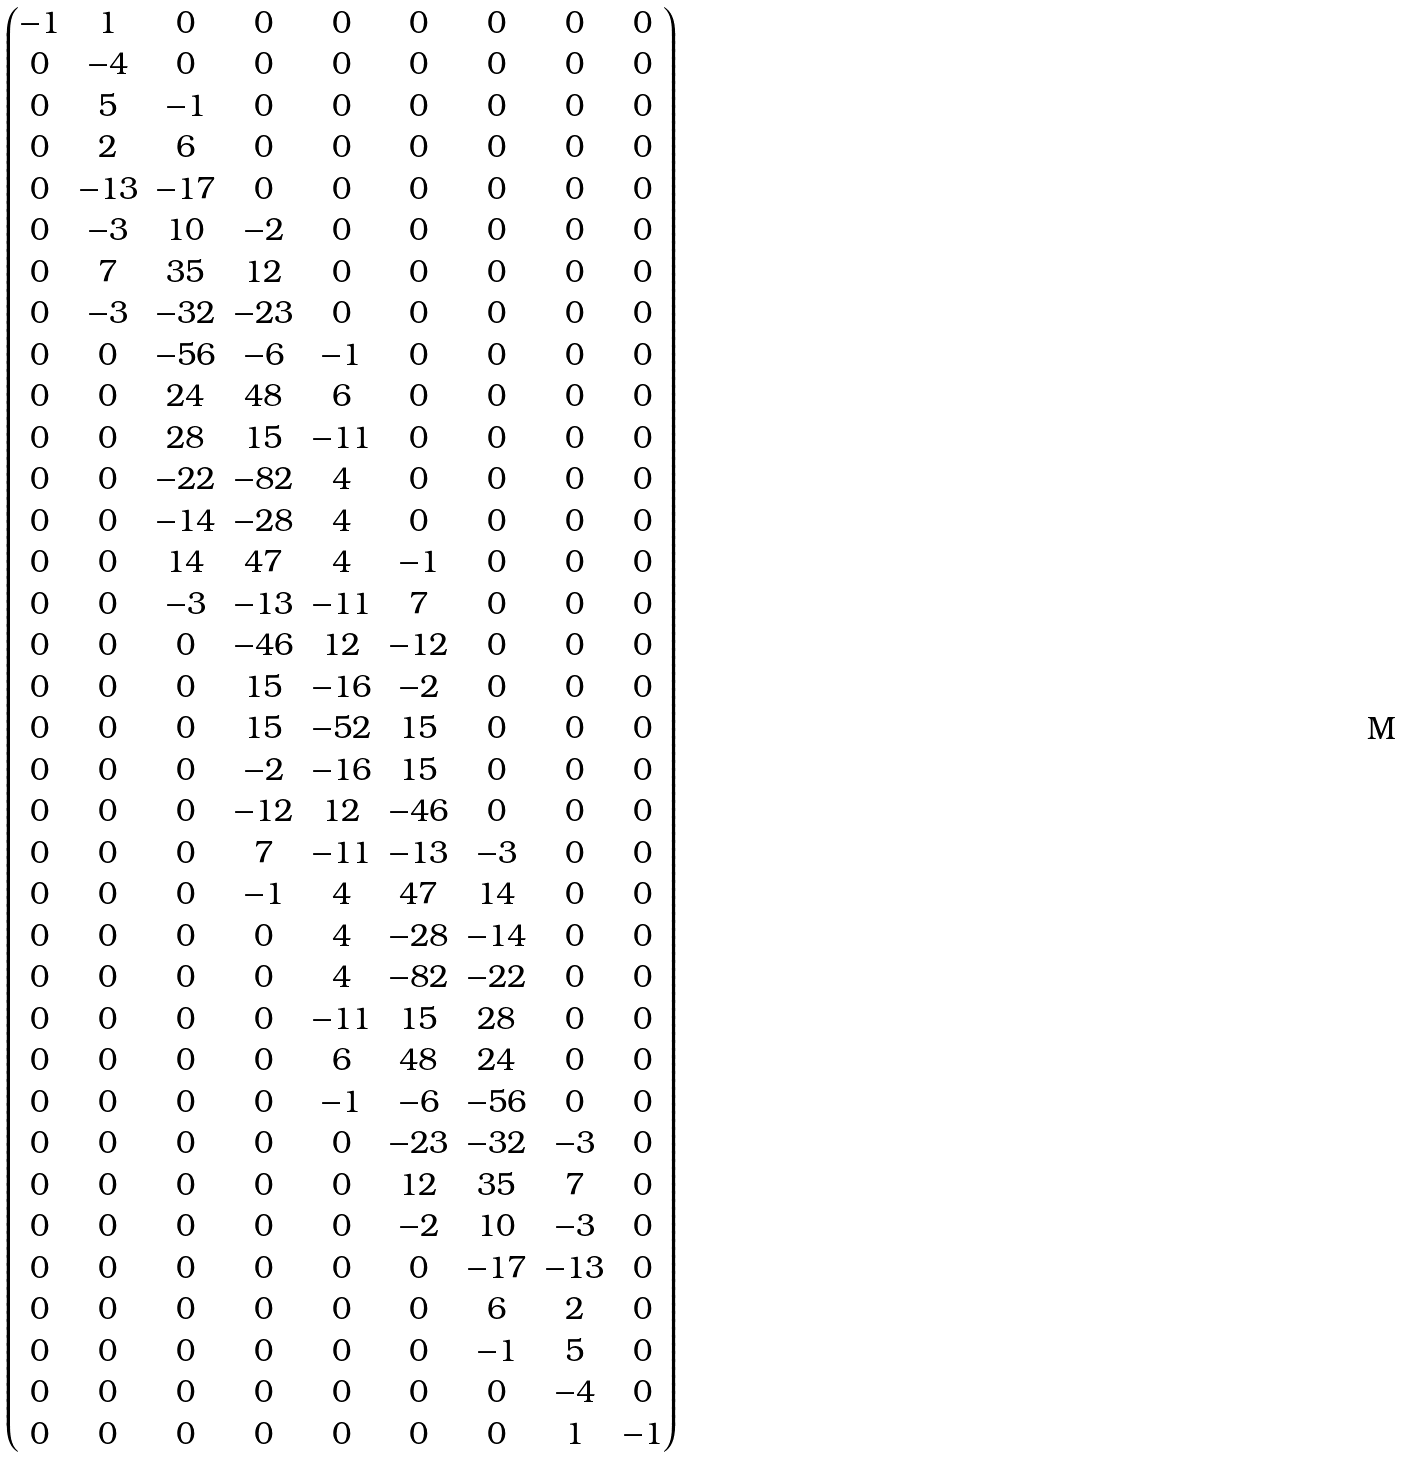Convert formula to latex. <formula><loc_0><loc_0><loc_500><loc_500>\begin{pmatrix} - 1 & 1 & 0 & 0 & 0 & 0 & 0 & 0 & 0 \\ 0 & - 4 & 0 & 0 & 0 & 0 & 0 & 0 & 0 \\ 0 & 5 & - 1 & 0 & 0 & 0 & 0 & 0 & 0 \\ 0 & 2 & 6 & 0 & 0 & 0 & 0 & 0 & 0 \\ 0 & - 1 3 & - 1 7 & 0 & 0 & 0 & 0 & 0 & 0 \\ 0 & - 3 & 1 0 & - 2 & 0 & 0 & 0 & 0 & 0 \\ 0 & 7 & 3 5 & 1 2 & 0 & 0 & 0 & 0 & 0 \\ 0 & - 3 & - 3 2 & - 2 3 & 0 & 0 & 0 & 0 & 0 \\ 0 & 0 & - 5 6 & - 6 & - 1 & 0 & 0 & 0 & 0 \\ 0 & 0 & 2 4 & 4 8 & 6 & 0 & 0 & 0 & 0 \\ 0 & 0 & 2 8 & 1 5 & - 1 1 & 0 & 0 & 0 & 0 \\ 0 & 0 & - 2 2 & - 8 2 & 4 & 0 & 0 & 0 & 0 \\ 0 & 0 & - 1 4 & - 2 8 & 4 & 0 & 0 & 0 & 0 \\ 0 & 0 & 1 4 & 4 7 & 4 & - 1 & 0 & 0 & 0 \\ 0 & 0 & - 3 & - 1 3 & - 1 1 & 7 & 0 & 0 & 0 \\ 0 & 0 & 0 & - 4 6 & 1 2 & - 1 2 & 0 & 0 & 0 \\ 0 & 0 & 0 & 1 5 & - 1 6 & - 2 & 0 & 0 & 0 \\ 0 & 0 & 0 & 1 5 & - 5 2 & 1 5 & 0 & 0 & 0 \\ 0 & 0 & 0 & - 2 & - 1 6 & 1 5 & 0 & 0 & 0 \\ 0 & 0 & 0 & - 1 2 & 1 2 & - 4 6 & 0 & 0 & 0 \\ 0 & 0 & 0 & 7 & - 1 1 & - 1 3 & - 3 & 0 & 0 \\ 0 & 0 & 0 & - 1 & 4 & 4 7 & 1 4 & 0 & 0 \\ 0 & 0 & 0 & 0 & 4 & - 2 8 & - 1 4 & 0 & 0 \\ 0 & 0 & 0 & 0 & 4 & - 8 2 & - 2 2 & 0 & 0 \\ 0 & 0 & 0 & 0 & - 1 1 & 1 5 & 2 8 & 0 & 0 \\ 0 & 0 & 0 & 0 & 6 & 4 8 & 2 4 & 0 & 0 \\ 0 & 0 & 0 & 0 & - 1 & - 6 & - 5 6 & 0 & 0 \\ 0 & 0 & 0 & 0 & 0 & - 2 3 & - 3 2 & - 3 & 0 \\ 0 & 0 & 0 & 0 & 0 & 1 2 & 3 5 & 7 & 0 \\ 0 & 0 & 0 & 0 & 0 & - 2 & 1 0 & - 3 & 0 \\ 0 & 0 & 0 & 0 & 0 & 0 & - 1 7 & - 1 3 & 0 \\ 0 & 0 & 0 & 0 & 0 & 0 & 6 & 2 & 0 \\ 0 & 0 & 0 & 0 & 0 & 0 & - 1 & 5 & 0 \\ 0 & 0 & 0 & 0 & 0 & 0 & 0 & - 4 & 0 \\ 0 & 0 & 0 & 0 & 0 & 0 & 0 & 1 & - 1 \\ \end{pmatrix}</formula> 